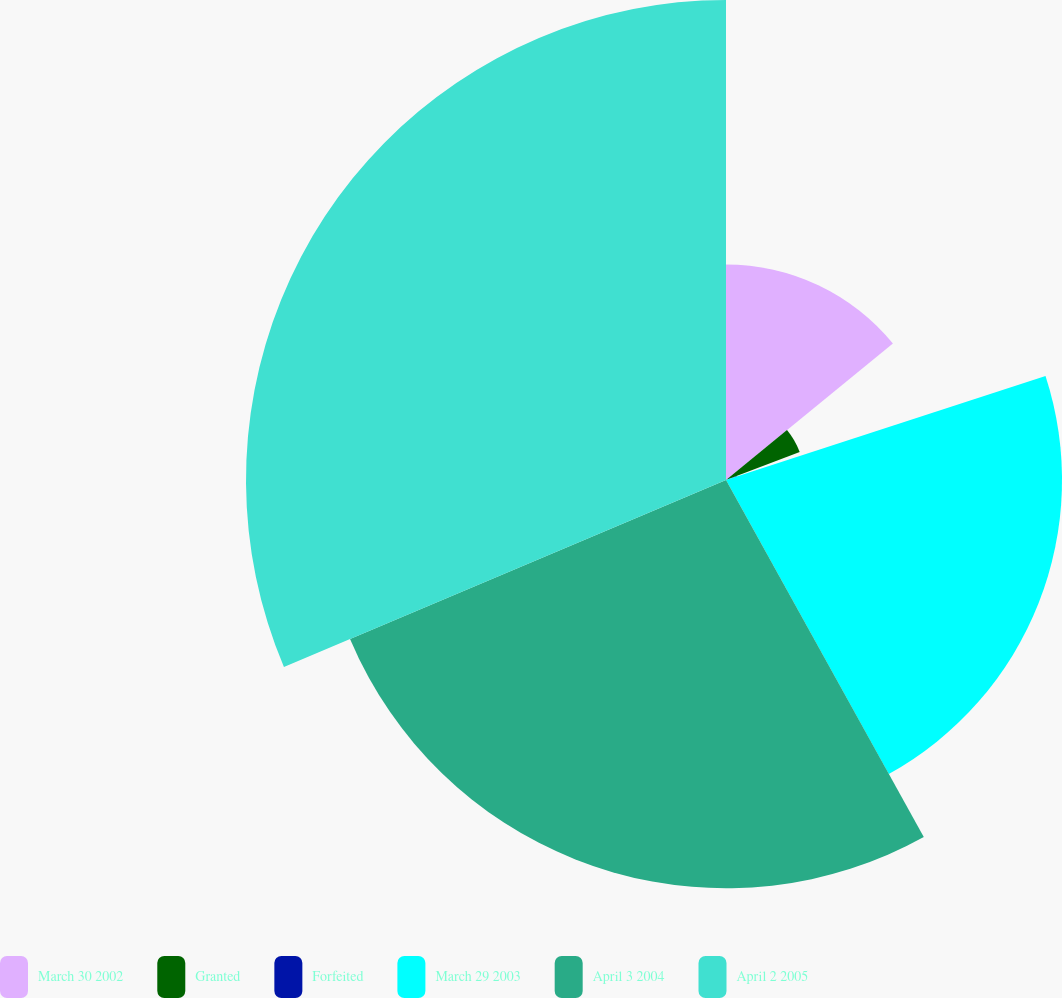<chart> <loc_0><loc_0><loc_500><loc_500><pie_chart><fcel>March 30 2002<fcel>Granted<fcel>Forfeited<fcel>March 29 2003<fcel>April 3 2004<fcel>April 2 2005<nl><fcel>14.09%<fcel>5.15%<fcel>0.75%<fcel>21.96%<fcel>26.68%<fcel>31.37%<nl></chart> 